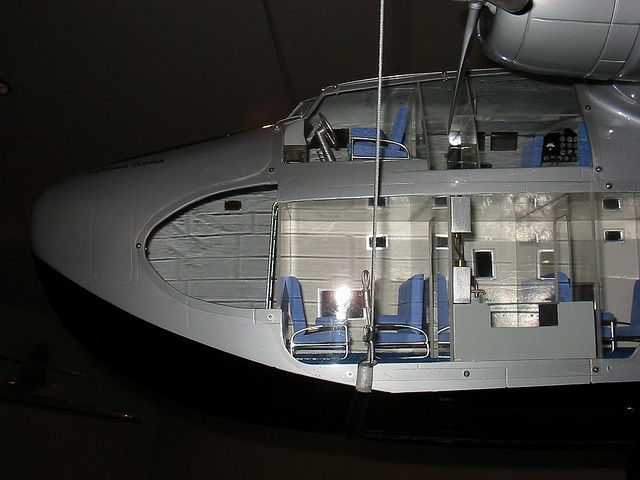Describe the objects in this image and their specific colors. I can see airplane in black, gray, darkgray, and lightgray tones, chair in black, gray, and blue tones, chair in black, gray, and darkgray tones, chair in black, gray, and blue tones, and chair in black, navy, gray, and darkblue tones in this image. 